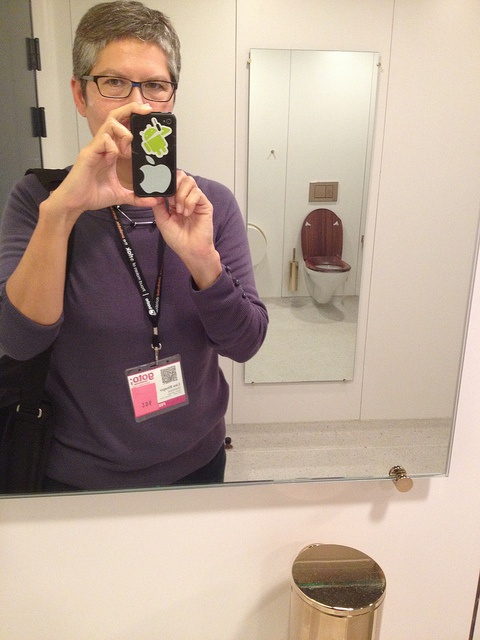Describe the objects in this image and their specific colors. I can see people in olive, black, purple, and gray tones, handbag in olive, black, and gray tones, cell phone in olive, black, darkgray, and beige tones, and toilet in olive, maroon, darkgray, brown, and gray tones in this image. 